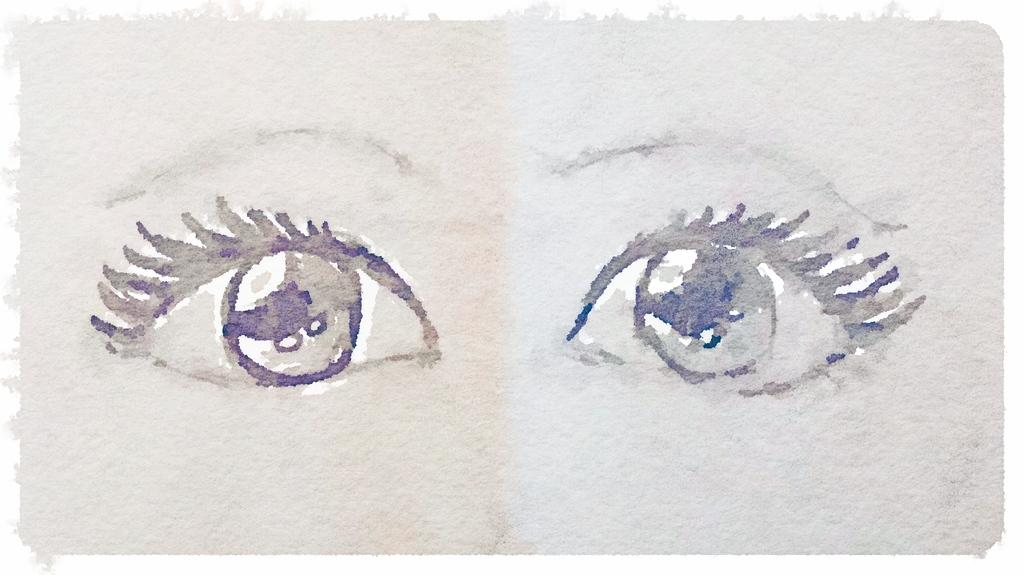What is the main subject of the painting in the image? The main subject of the painting in the image is human eyes. What color is the background of the image? The background of the image is white. How many cattle are visible in the image? There are no cattle present in the image. What type of books are being read by the eyes in the painting? The painting features human eyes and does not depict any books. 